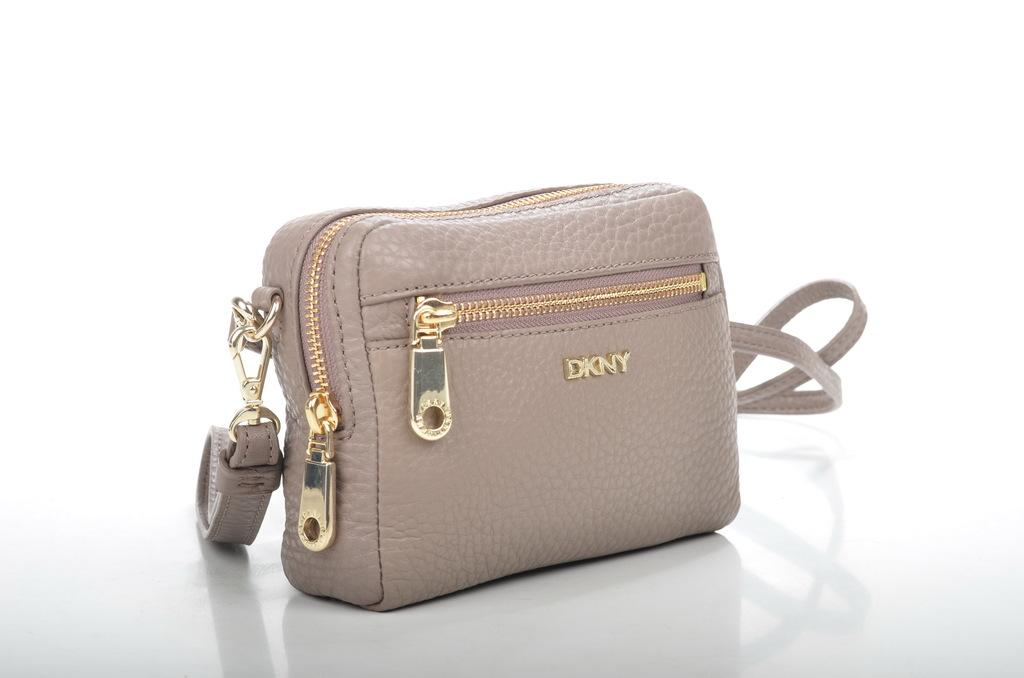What type of accessory is visible in the image? There is a handbag in the image. Can you hear the committee discussing the engine's performance in the image? There is no mention of a committee, engine, or any discussion in the image; it only features a handbag. 